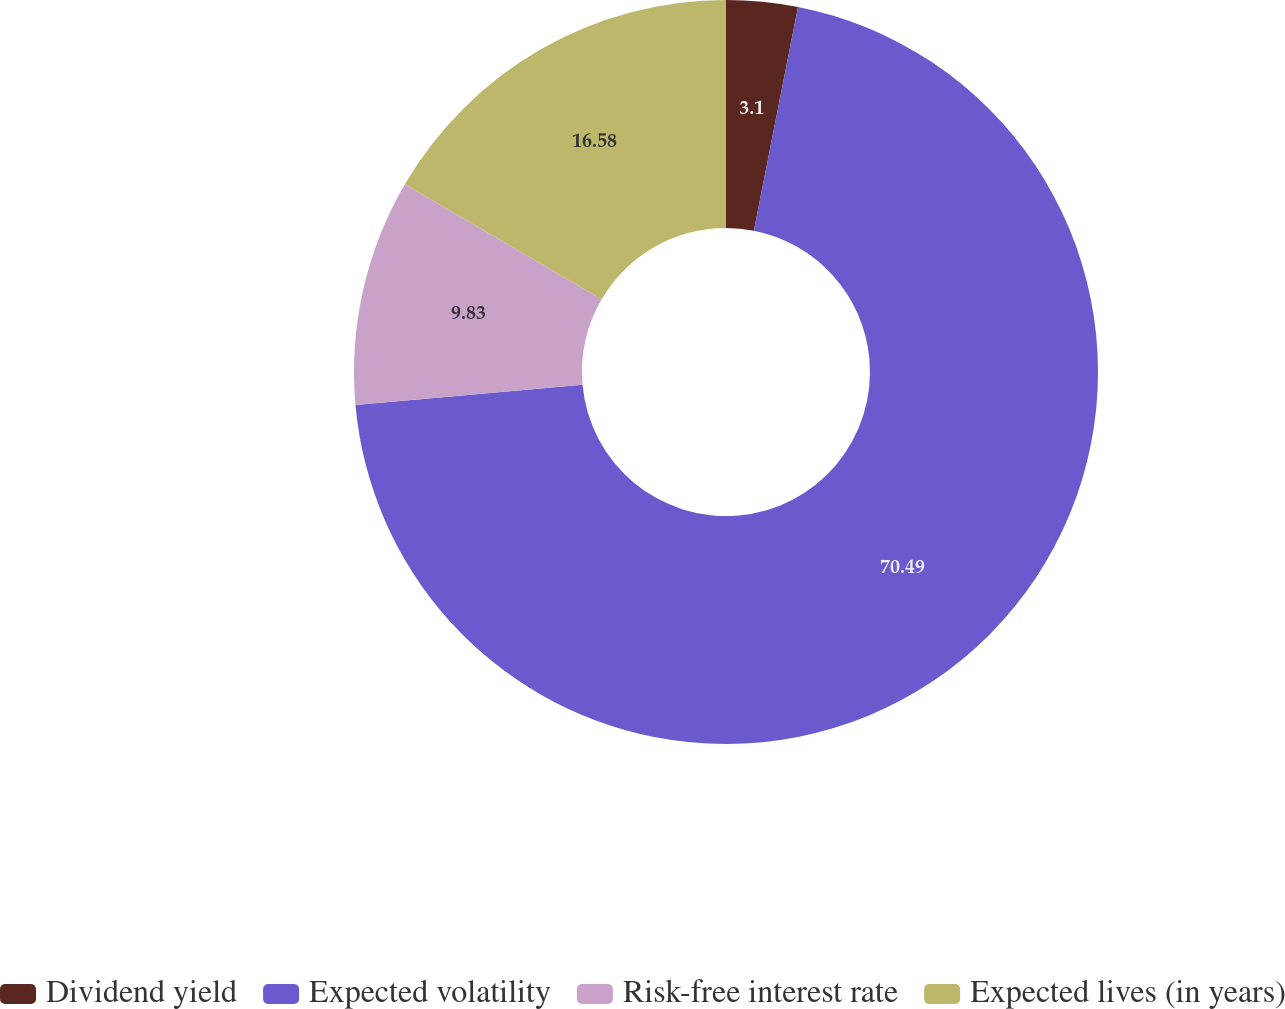<chart> <loc_0><loc_0><loc_500><loc_500><pie_chart><fcel>Dividend yield<fcel>Expected volatility<fcel>Risk-free interest rate<fcel>Expected lives (in years)<nl><fcel>3.1%<fcel>70.49%<fcel>9.83%<fcel>16.58%<nl></chart> 